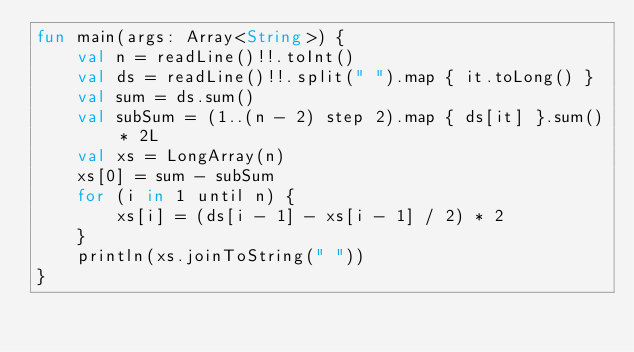Convert code to text. <code><loc_0><loc_0><loc_500><loc_500><_Kotlin_>fun main(args: Array<String>) {
    val n = readLine()!!.toInt()
    val ds = readLine()!!.split(" ").map { it.toLong() }
    val sum = ds.sum()
    val subSum = (1..(n - 2) step 2).map { ds[it] }.sum() * 2L
    val xs = LongArray(n)
    xs[0] = sum - subSum
    for (i in 1 until n) {
        xs[i] = (ds[i - 1] - xs[i - 1] / 2) * 2
    }
    println(xs.joinToString(" "))
}</code> 